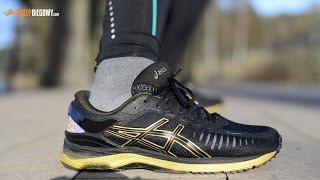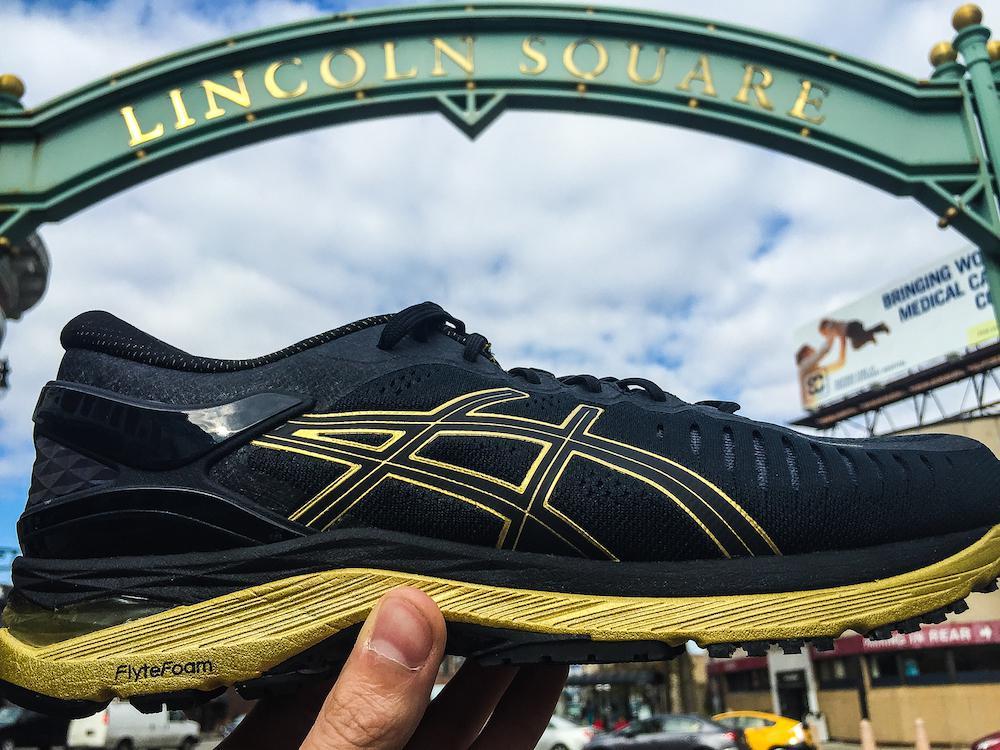The first image is the image on the left, the second image is the image on the right. Assess this claim about the two images: "There is a running shoe presented by a robotic arm in at least one of the images.". Correct or not? Answer yes or no. No. 